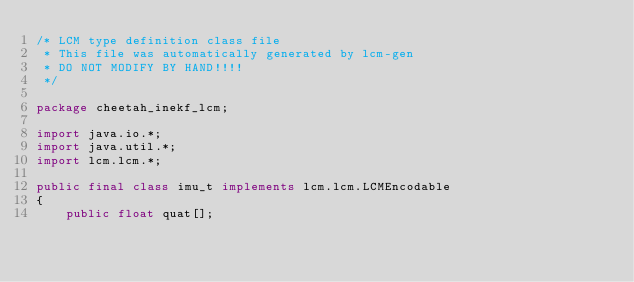<code> <loc_0><loc_0><loc_500><loc_500><_Java_>/* LCM type definition class file
 * This file was automatically generated by lcm-gen
 * DO NOT MODIFY BY HAND!!!!
 */

package cheetah_inekf_lcm;
 
import java.io.*;
import java.util.*;
import lcm.lcm.*;
 
public final class imu_t implements lcm.lcm.LCMEncodable
{
    public float quat[];</code> 